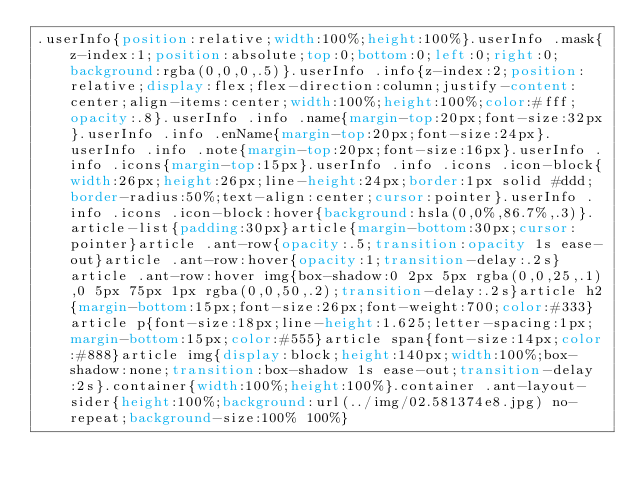Convert code to text. <code><loc_0><loc_0><loc_500><loc_500><_CSS_>.userInfo{position:relative;width:100%;height:100%}.userInfo .mask{z-index:1;position:absolute;top:0;bottom:0;left:0;right:0;background:rgba(0,0,0,.5)}.userInfo .info{z-index:2;position:relative;display:flex;flex-direction:column;justify-content:center;align-items:center;width:100%;height:100%;color:#fff;opacity:.8}.userInfo .info .name{margin-top:20px;font-size:32px}.userInfo .info .enName{margin-top:20px;font-size:24px}.userInfo .info .note{margin-top:20px;font-size:16px}.userInfo .info .icons{margin-top:15px}.userInfo .info .icons .icon-block{width:26px;height:26px;line-height:24px;border:1px solid #ddd;border-radius:50%;text-align:center;cursor:pointer}.userInfo .info .icons .icon-block:hover{background:hsla(0,0%,86.7%,.3)}.article-list{padding:30px}article{margin-bottom:30px;cursor:pointer}article .ant-row{opacity:.5;transition:opacity 1s ease-out}article .ant-row:hover{opacity:1;transition-delay:.2s}article .ant-row:hover img{box-shadow:0 2px 5px rgba(0,0,25,.1),0 5px 75px 1px rgba(0,0,50,.2);transition-delay:.2s}article h2{margin-bottom:15px;font-size:26px;font-weight:700;color:#333}article p{font-size:18px;line-height:1.625;letter-spacing:1px;margin-bottom:15px;color:#555}article span{font-size:14px;color:#888}article img{display:block;height:140px;width:100%;box-shadow:none;transition:box-shadow 1s ease-out;transition-delay:2s}.container{width:100%;height:100%}.container .ant-layout-sider{height:100%;background:url(../img/02.581374e8.jpg) no-repeat;background-size:100% 100%}</code> 